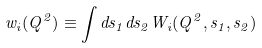<formula> <loc_0><loc_0><loc_500><loc_500>w _ { i } ( Q ^ { 2 } ) \equiv \int d s _ { 1 } d s _ { 2 } W _ { i } ( Q ^ { 2 } , s _ { 1 } , s _ { 2 } )</formula> 